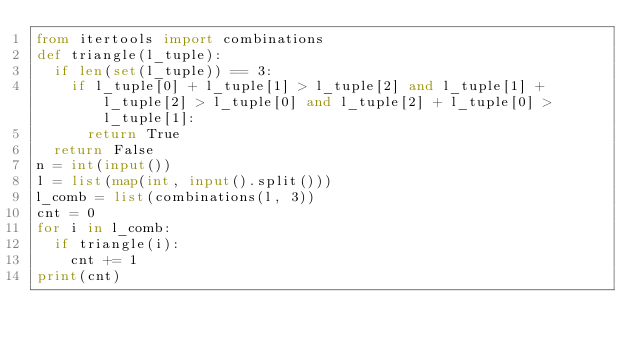<code> <loc_0><loc_0><loc_500><loc_500><_Python_>from itertools import combinations
def triangle(l_tuple):
  if len(set(l_tuple)) == 3:
    if l_tuple[0] + l_tuple[1] > l_tuple[2] and l_tuple[1] + l_tuple[2] > l_tuple[0] and l_tuple[2] + l_tuple[0] > l_tuple[1]:
      return True
  return False
n = int(input())
l = list(map(int, input().split()))
l_comb = list(combinations(l, 3))
cnt = 0
for i in l_comb:
  if triangle(i):
    cnt += 1
print(cnt)</code> 